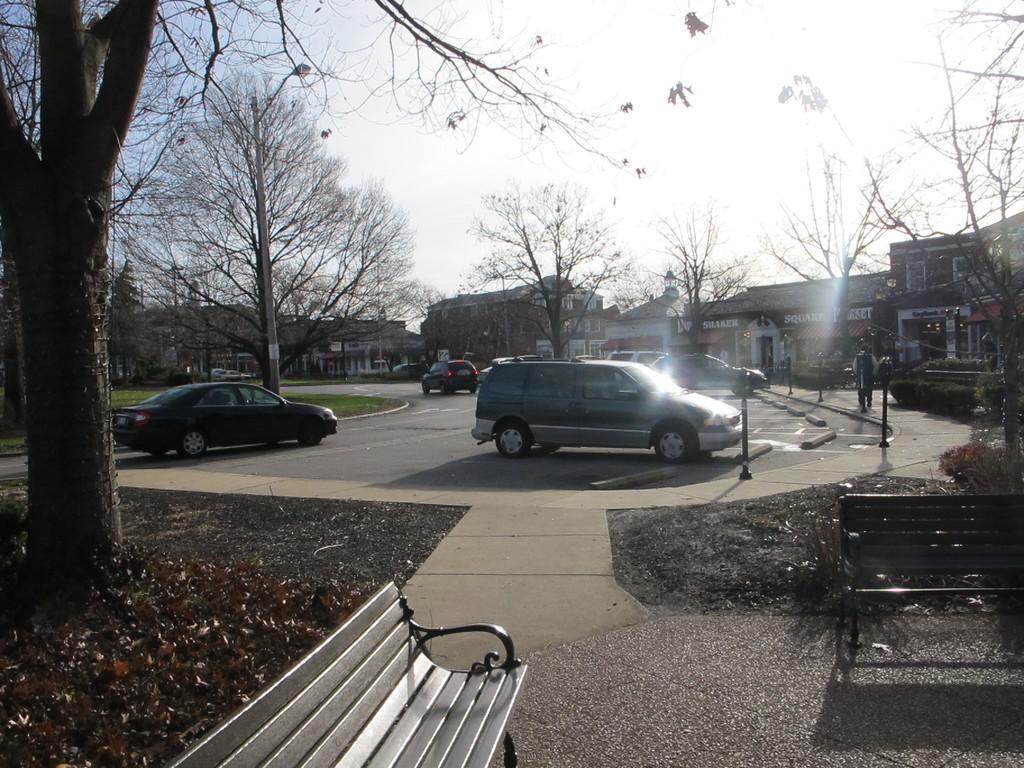In one or two sentences, can you explain what this image depicts? In this image we can see benches, cars, buildings, trees and poles. On the road a person is moving. To the left side of the image dry leaves are present on the floor. 